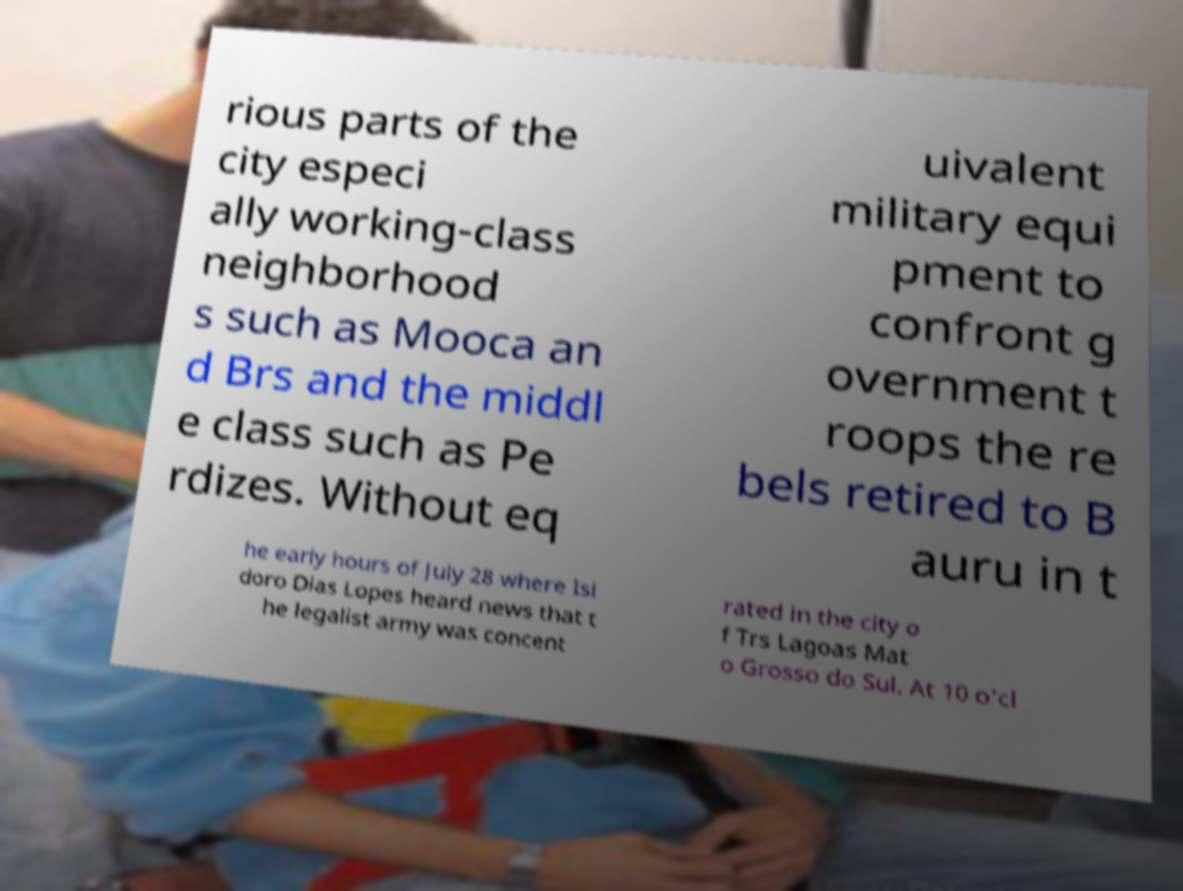There's text embedded in this image that I need extracted. Can you transcribe it verbatim? rious parts of the city especi ally working-class neighborhood s such as Mooca an d Brs and the middl e class such as Pe rdizes. Without eq uivalent military equi pment to confront g overnment t roops the re bels retired to B auru in t he early hours of July 28 where Isi doro Dias Lopes heard news that t he legalist army was concent rated in the city o f Trs Lagoas Mat o Grosso do Sul. At 10 o'cl 